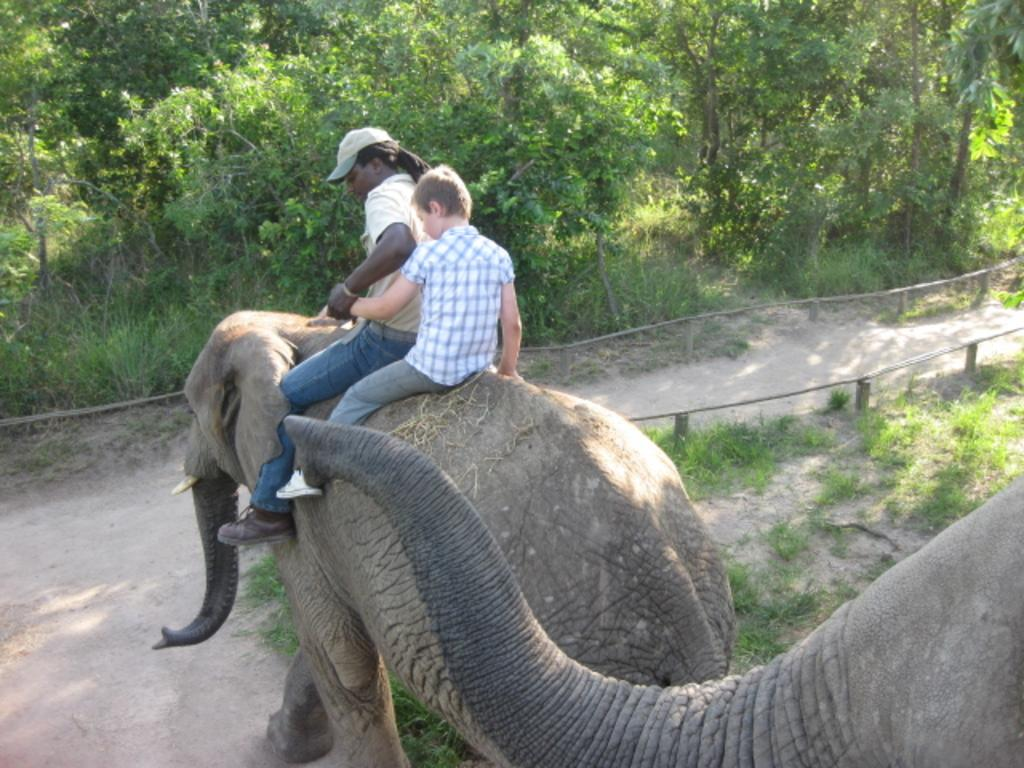How many people are in the image? There are two people in the image. What are the two people doing in the image? The two people are sitting on an elephant. How many elephants are in the image? There are two elephants in the image. What can be seen in the background of the image? There are plants and trees in the background of the image. Can you describe the mother crow sitting on the edge of the elephant in the image? There is no crow, let alone a mother crow, present in the image. 